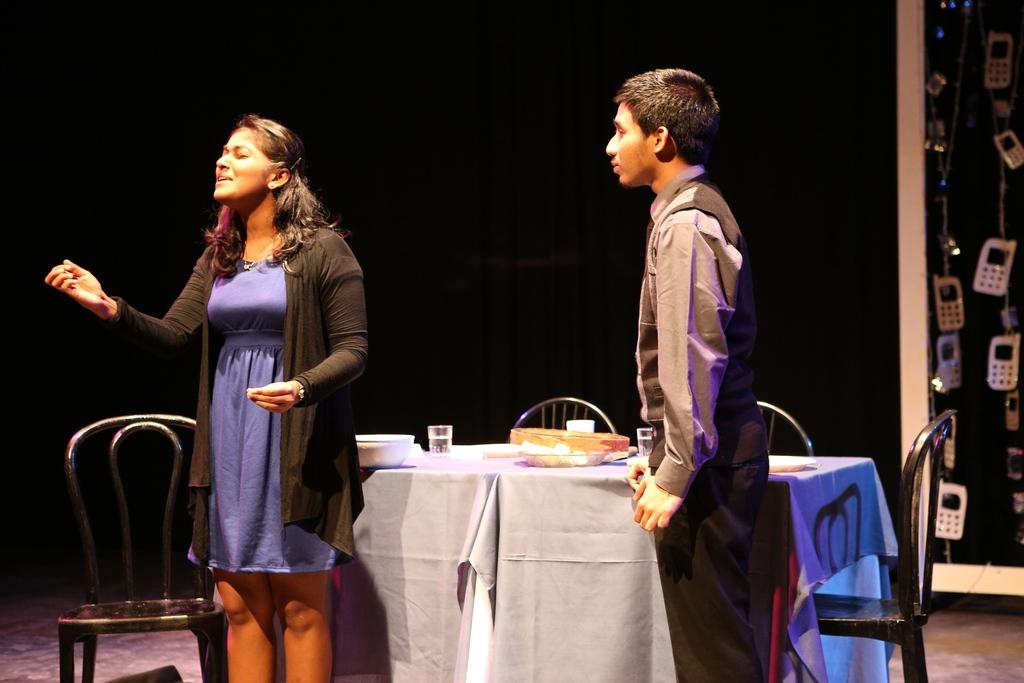How many people are in the image? There are two people in the image, a woman and a man. What are the positions of the woman and the man in the image? Both the woman and the man are standing on the ground. What furniture is present in the image? There is a table and chairs in the image. What type of stocking is the actor wearing in the image? There is no actor or stocking present in the image. How does the crook plan to use the table in the image? There is no crook or indication of any criminal activity in the image. 